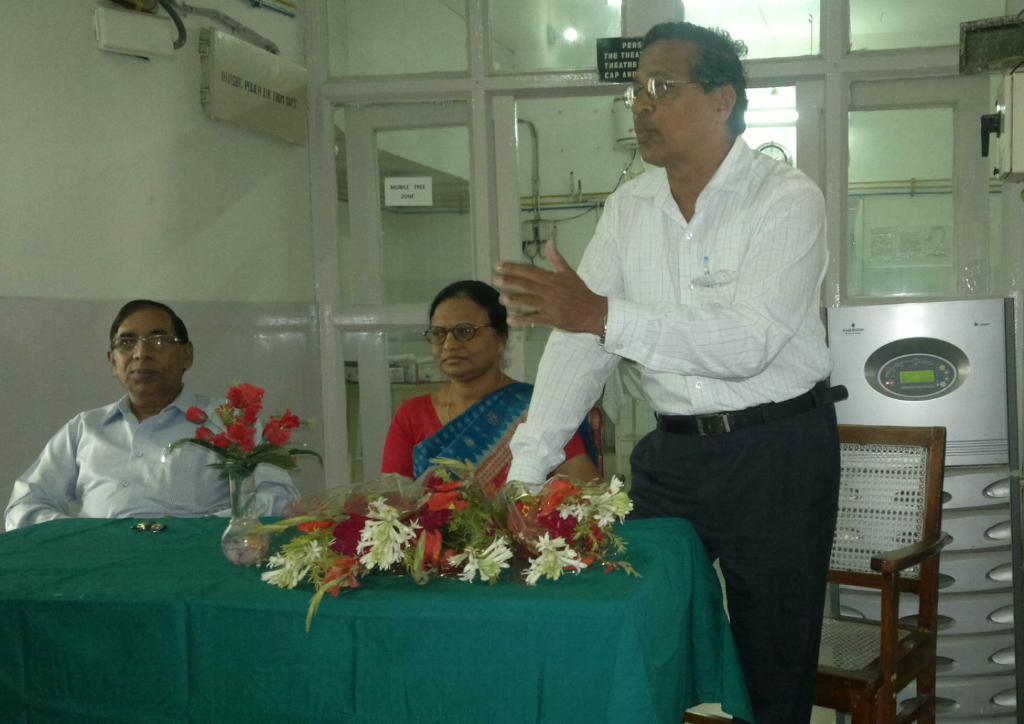How would you summarize this image in a sentence or two? This image is taken indoors. At the bottom of the image there is a table with a tablecloth, a flower vase and a bouquet on it. On the right side of the image there is a machine and there is an empty chair. On the left side of the image a man is sitting on the chair. In the middle of the image a man is standing on the floor and a woman is sitting on the chair. In the background there is a wall and there is a glass door. There is a board with a text on it. 